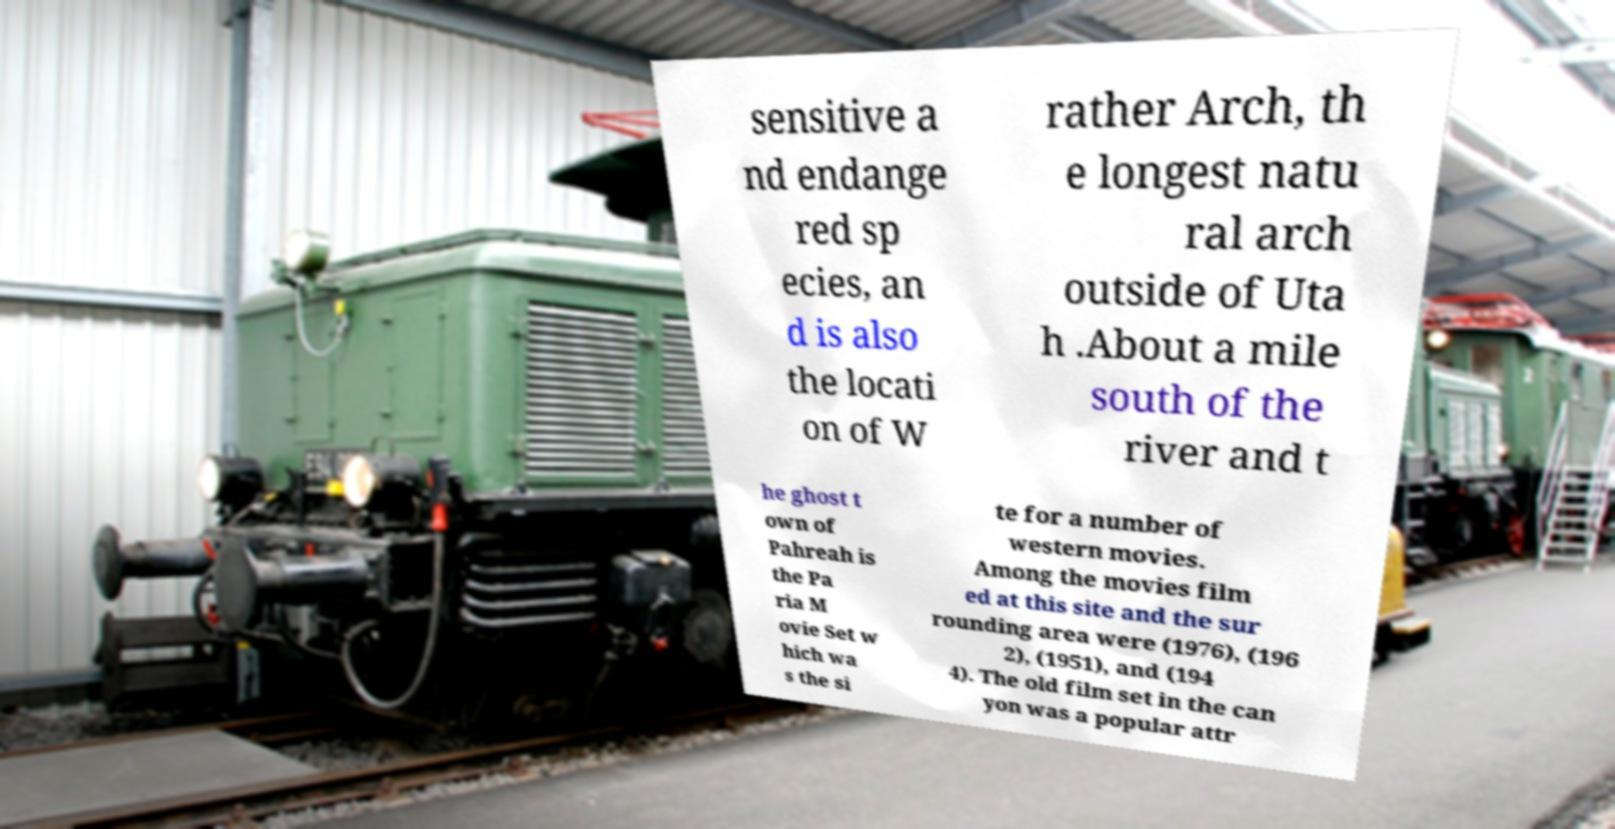Please identify and transcribe the text found in this image. sensitive a nd endange red sp ecies, an d is also the locati on of W rather Arch, th e longest natu ral arch outside of Uta h .About a mile south of the river and t he ghost t own of Pahreah is the Pa ria M ovie Set w hich wa s the si te for a number of western movies. Among the movies film ed at this site and the sur rounding area were (1976), (196 2), (1951), and (194 4). The old film set in the can yon was a popular attr 